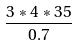<formula> <loc_0><loc_0><loc_500><loc_500>\frac { 3 * 4 * 3 5 } { 0 . 7 }</formula> 